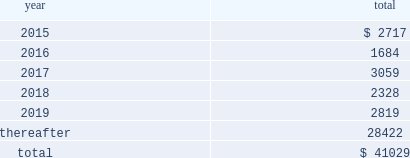Maturities of debt the scheduled maturities of the outstanding debt balances , excluding debt fair value adjustments as of december 31 , 2014 , are summarized as follows ( in millions ) : .
_______ interest rates , interest rate swaps and contingent debt the weighted average interest rate on all of our borrowings was 5.02% ( 5.02 % ) during 2014 and 5.08% ( 5.08 % ) during 2013 .
Information on our interest rate swaps is contained in note 13 .
For information about our contingent debt agreements , see note 12 .
Subsequent event subsequent to december 31 , 2014 , additional ep trust i preferred securities were converted , primarily consisting of 969117 ep trust i preferred securities converted on january 14 , 2015 , into ( i ) 697473 of our class p common stock ; ( ii ) approximately $ 24 million in cash ; and ( iii ) 1066028 in warrants .
Share-based compensation and employee benefits share-based compensation kinder morgan , inc .
Class p shares stock compensation plan for non-employee directors we have a stock compensation plan for non-employee directors , in which our eligible non-employee directors participate .
The plan recognizes that the compensation paid to each eligible non-employee director is fixed by our board , generally annually , and that the compensation is payable in cash .
Pursuant to the plan , in lieu of receiving some or all of the cash compensation , each eligible non-employee director may elect to receive shares of class p common stock .
Each election will be generally at or around the first board meeting in january of each calendar year and will be effective for the entire calendar year .
An eligible director may make a new election each calendar year .
The total number of shares of class p common stock authorized under the plan is 250000 .
During 2014 , 2013 and 2012 , we made restricted class p common stock grants to our non-employee directors of 6210 , 5710 and 5520 , respectively .
These grants were valued at time of issuance at $ 220000 , $ 210000 and $ 185000 , respectively .
All of the restricted stock grants made to non-employee directors vest during a six-month period .
Table of contents .
What percentage of total maturities of debt come due prior to 2019? 
Computations: ((41029 - 28422) / 41029)
Answer: 0.30727. 